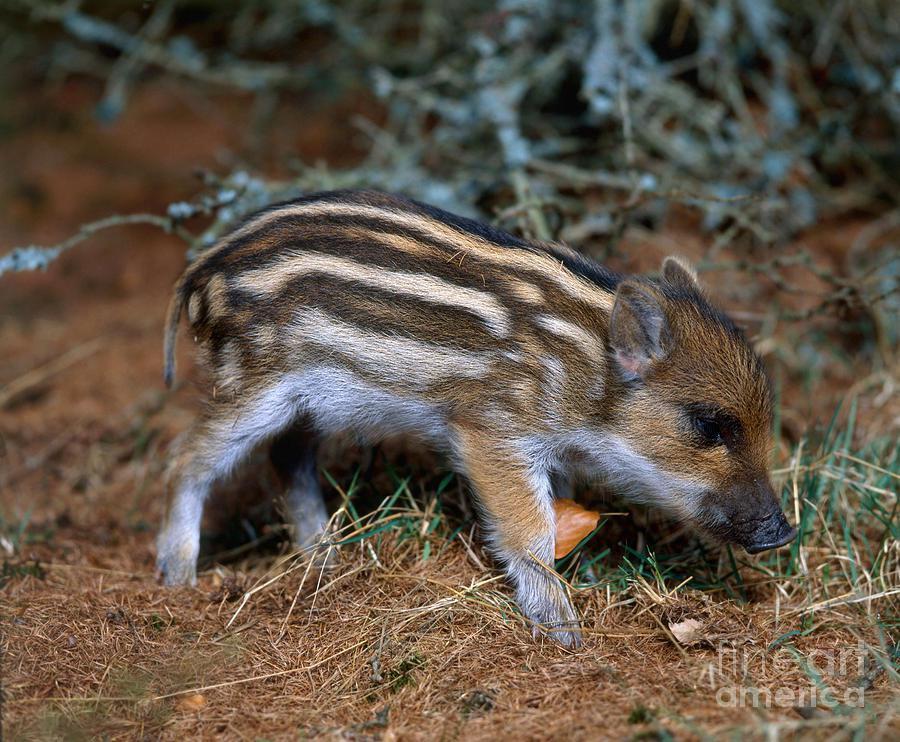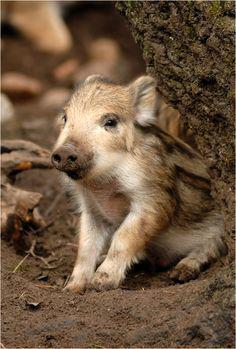The first image is the image on the left, the second image is the image on the right. For the images displayed, is the sentence "There are more pigs in the right image than in the left image." factually correct? Answer yes or no. No. The first image is the image on the left, the second image is the image on the right. Analyze the images presented: Is the assertion "There are at most three boar piglets." valid? Answer yes or no. Yes. 